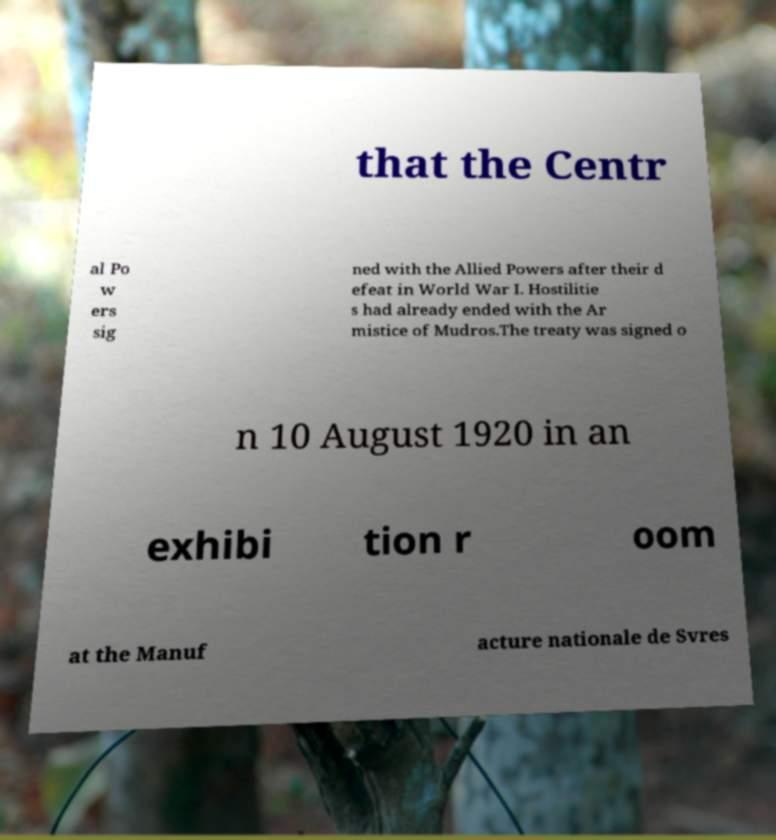Can you read and provide the text displayed in the image?This photo seems to have some interesting text. Can you extract and type it out for me? that the Centr al Po w ers sig ned with the Allied Powers after their d efeat in World War I. Hostilitie s had already ended with the Ar mistice of Mudros.The treaty was signed o n 10 August 1920 in an exhibi tion r oom at the Manuf acture nationale de Svres 